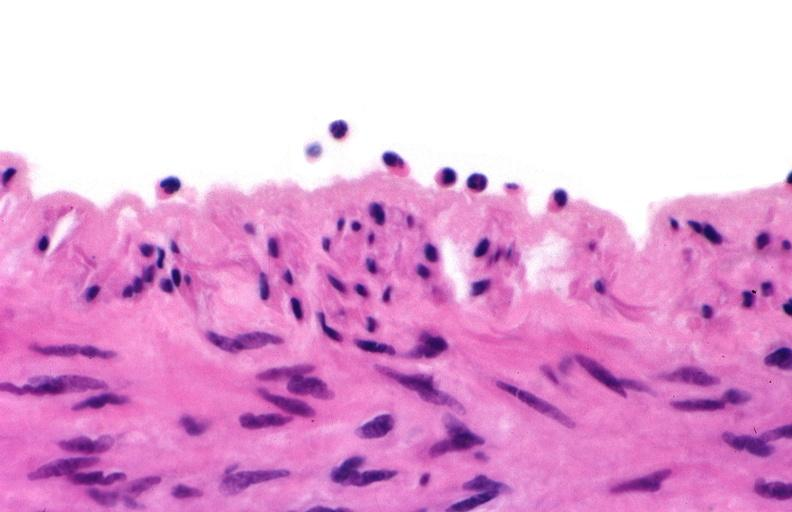what does this image show?
Answer the question using a single word or phrase. Acute inflammation 